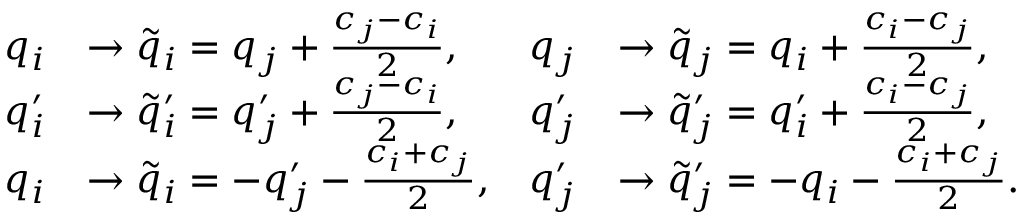<formula> <loc_0><loc_0><loc_500><loc_500>\begin{array} { r l r l } { q _ { i } } & { \to \tilde { q } _ { i } = q _ { j } + \frac { c _ { j } - c _ { i } } { 2 } , } & { q _ { j } } & { \to \tilde { q } _ { j } = q _ { i } + \frac { c _ { i } - c _ { j } } { 2 } , } \\ { q _ { i } ^ { \prime } } & { \to \tilde { q } _ { i } ^ { \prime } = q _ { j } ^ { \prime } + \frac { c _ { j } - c _ { i } } { 2 } , } & { q _ { j } ^ { \prime } } & { \to \tilde { q } _ { j } ^ { \prime } = q _ { i } ^ { \prime } + \frac { c _ { i } - c _ { j } } { 2 } , } \\ { q _ { i } } & { \to \tilde { q } _ { i } = - q _ { j } ^ { \prime } - \frac { c _ { i } + c _ { j } } { 2 } , } & { q _ { j } ^ { \prime } } & { \to \tilde { q } _ { j } ^ { \prime } = - q _ { i } - \frac { c _ { i } + c _ { j } } { 2 } . } \end{array}</formula> 